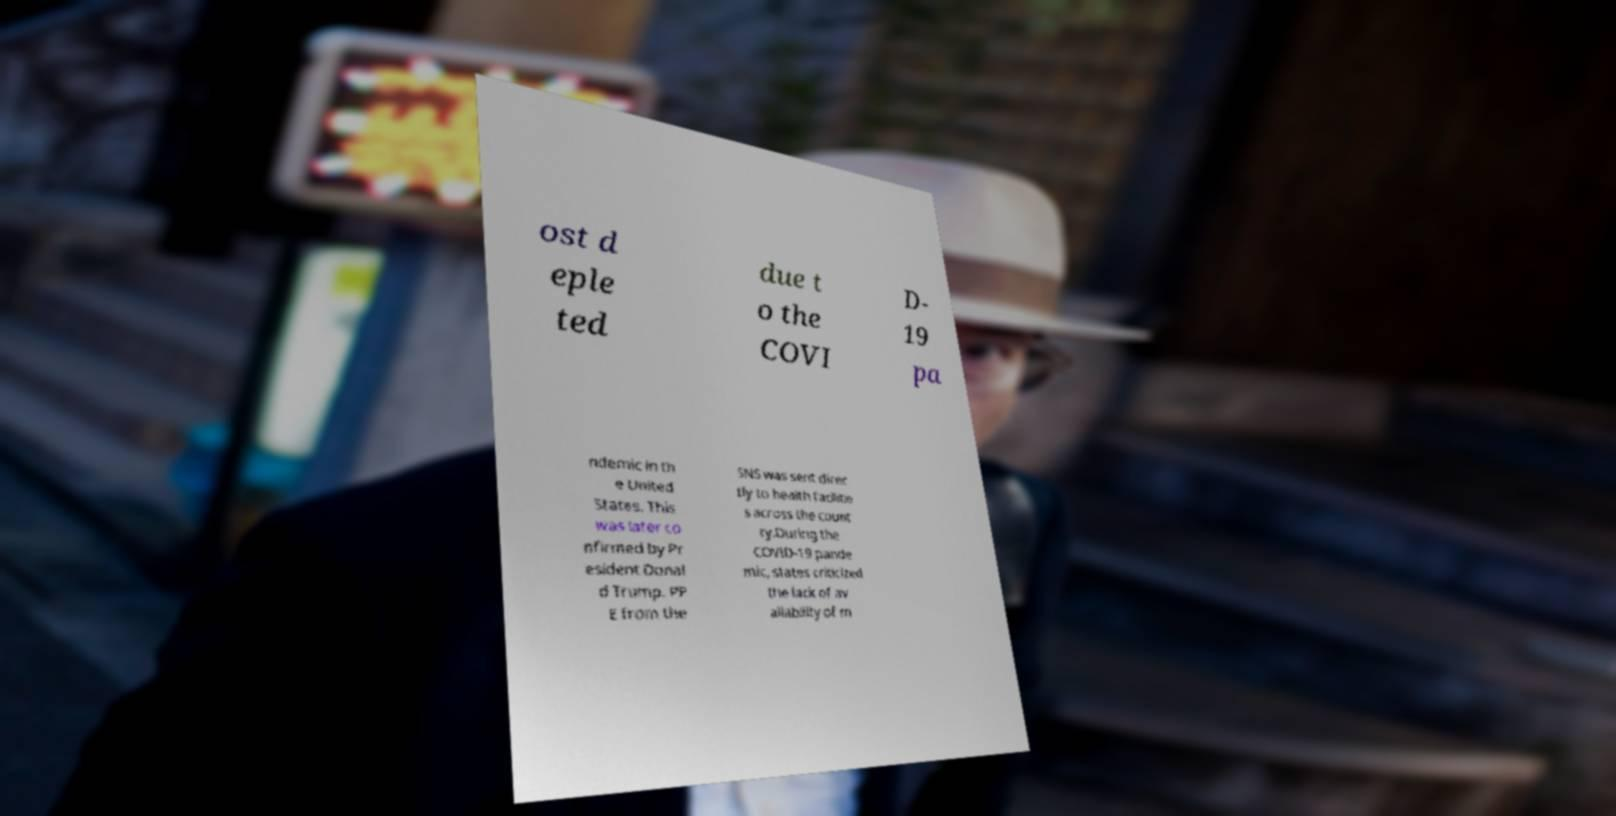Can you accurately transcribe the text from the provided image for me? ost d eple ted due t o the COVI D- 19 pa ndemic in th e United States. This was later co nfirmed by Pr esident Donal d Trump. PP E from the SNS was sent direc tly to health facilitie s across the count ry.During the COVID-19 pande mic, states criticized the lack of av ailability of m 